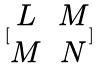<formula> <loc_0><loc_0><loc_500><loc_500>[ \begin{matrix} L & M \\ M & N \end{matrix} ]</formula> 